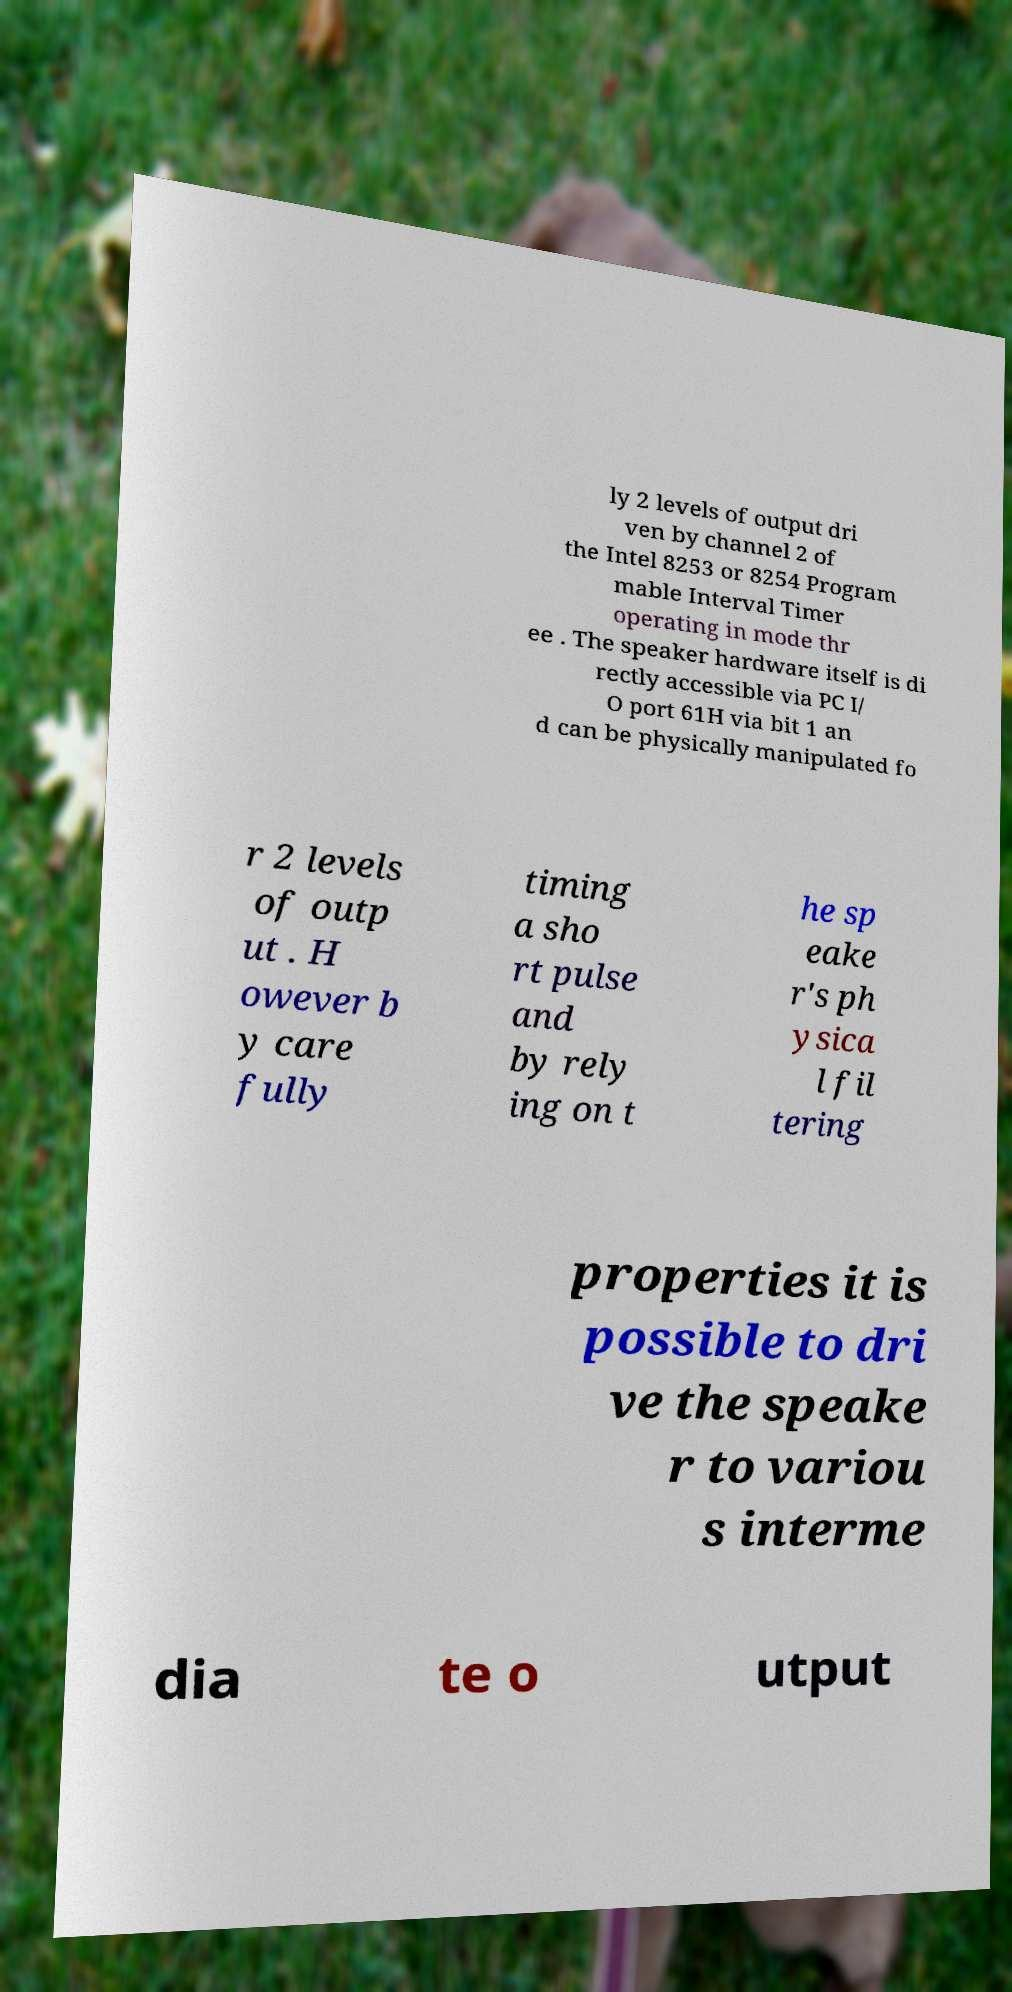Could you assist in decoding the text presented in this image and type it out clearly? ly 2 levels of output dri ven by channel 2 of the Intel 8253 or 8254 Program mable Interval Timer operating in mode thr ee . The speaker hardware itself is di rectly accessible via PC I/ O port 61H via bit 1 an d can be physically manipulated fo r 2 levels of outp ut . H owever b y care fully timing a sho rt pulse and by rely ing on t he sp eake r's ph ysica l fil tering properties it is possible to dri ve the speake r to variou s interme dia te o utput 